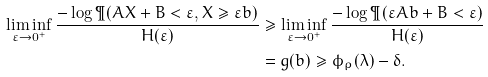Convert formula to latex. <formula><loc_0><loc_0><loc_500><loc_500>\liminf _ { \varepsilon \to 0 ^ { + } } \frac { - \log \P ( A X + B < \varepsilon , X \geq \varepsilon b ) } { H ( \varepsilon ) } & \geq \liminf _ { \varepsilon \to 0 ^ { + } } \frac { - \log \P ( \varepsilon A b + B < \varepsilon ) } { H ( \varepsilon ) } \\ & = g ( b ) \geq \phi _ { \rho } ( \lambda ) - \delta .</formula> 